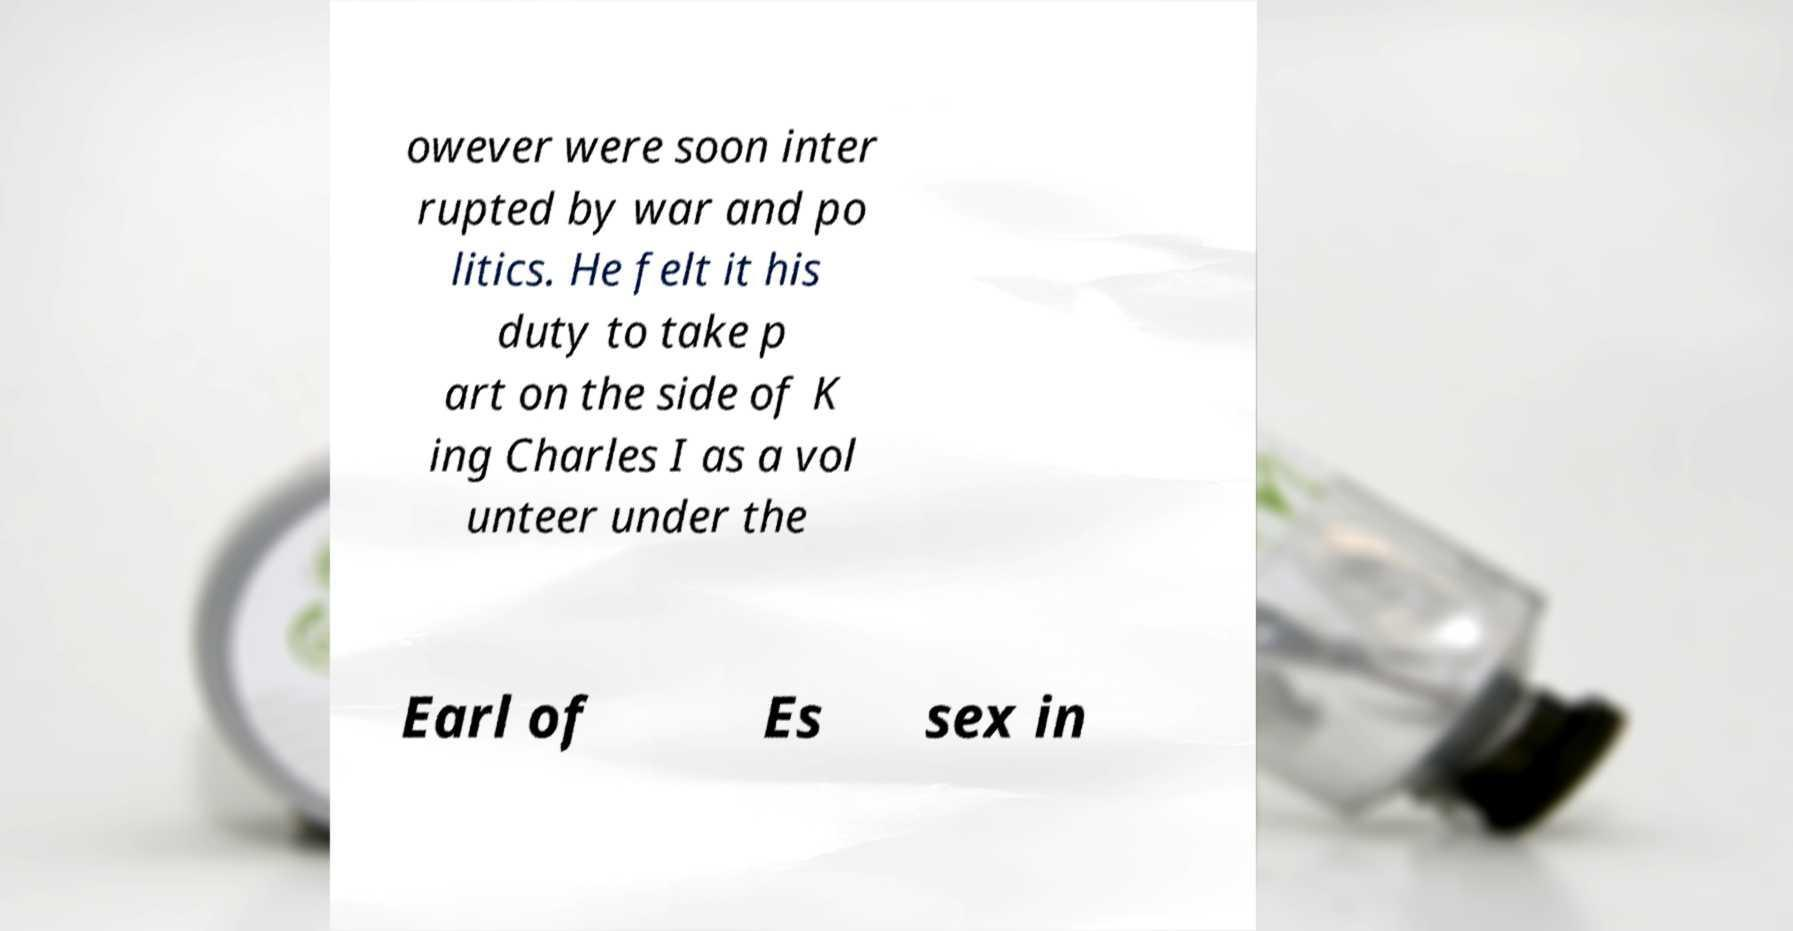Could you extract and type out the text from this image? owever were soon inter rupted by war and po litics. He felt it his duty to take p art on the side of K ing Charles I as a vol unteer under the Earl of Es sex in 